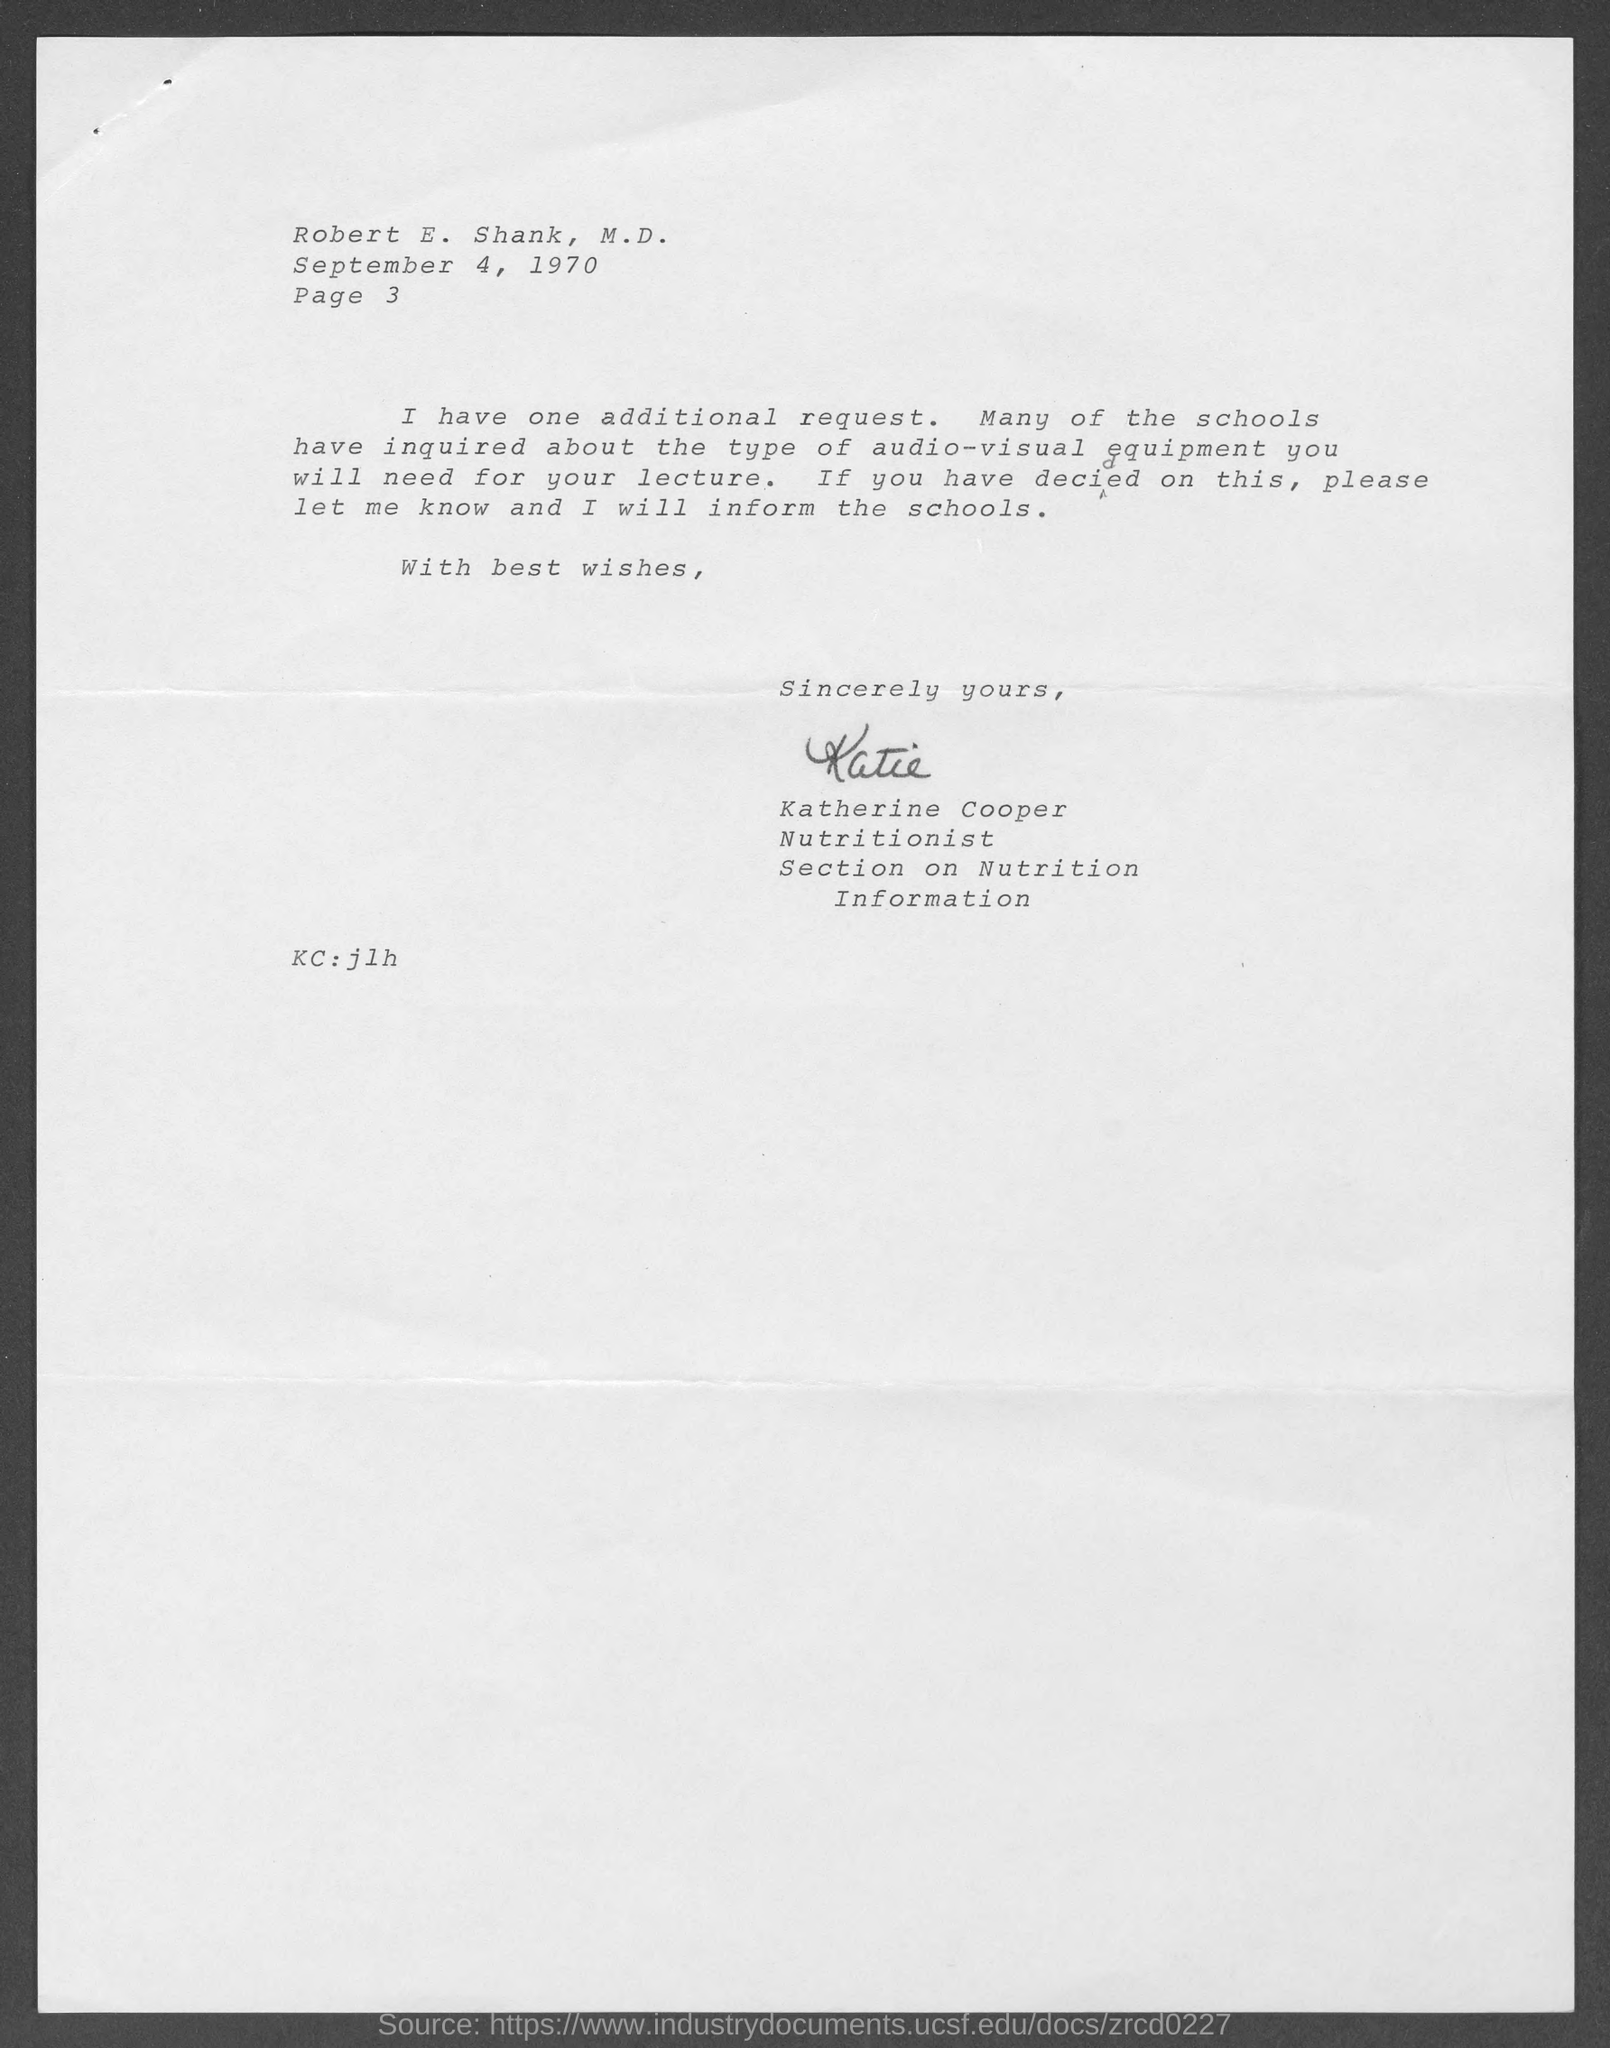Give some essential details in this illustration. The memorandum is dated on September 4, 1970. The "KC" field contains the written text of 'jlh'. The document contains a reference to page 3. 